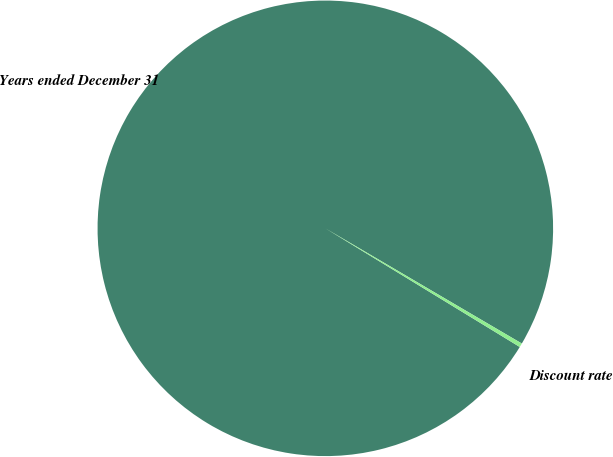Convert chart. <chart><loc_0><loc_0><loc_500><loc_500><pie_chart><fcel>Years ended December 31<fcel>Discount rate<nl><fcel>99.72%<fcel>0.28%<nl></chart> 